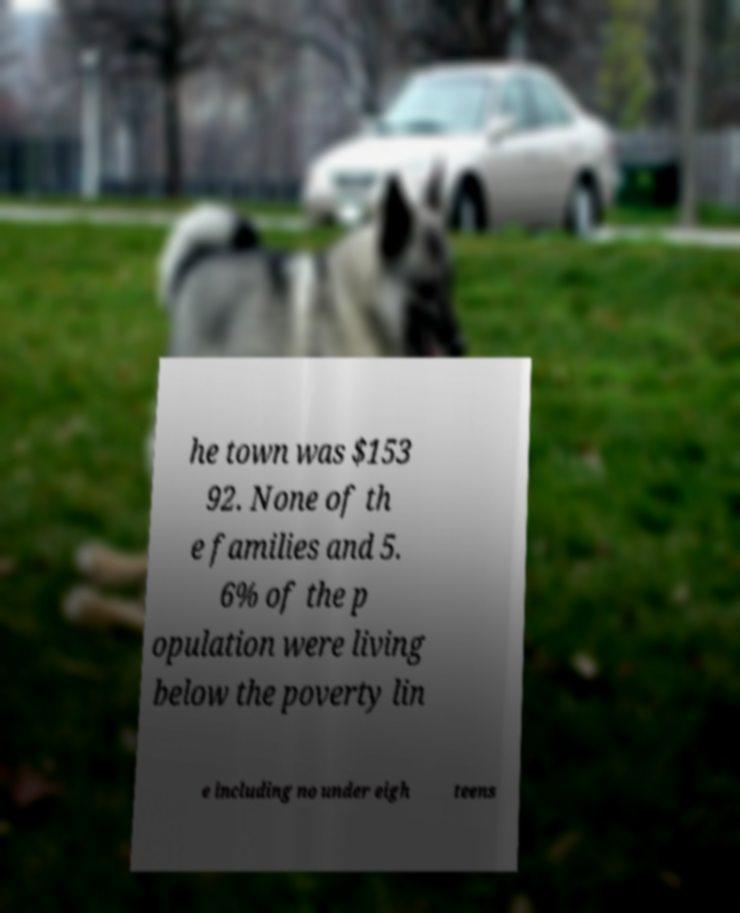Please read and relay the text visible in this image. What does it say? he town was $153 92. None of th e families and 5. 6% of the p opulation were living below the poverty lin e including no under eigh teens 